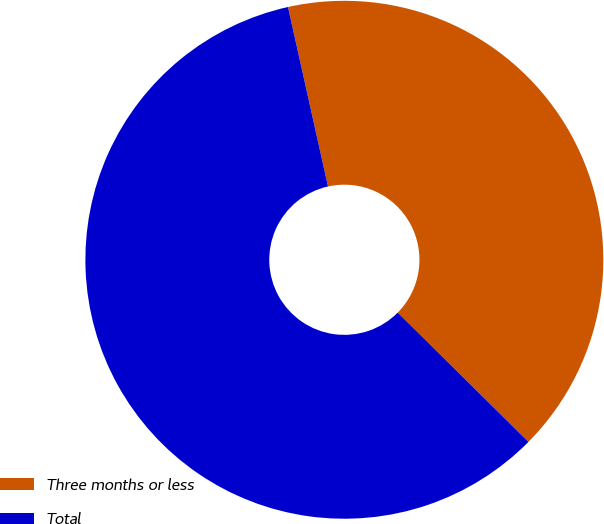<chart> <loc_0><loc_0><loc_500><loc_500><pie_chart><fcel>Three months or less<fcel>Total<nl><fcel>40.91%<fcel>59.09%<nl></chart> 